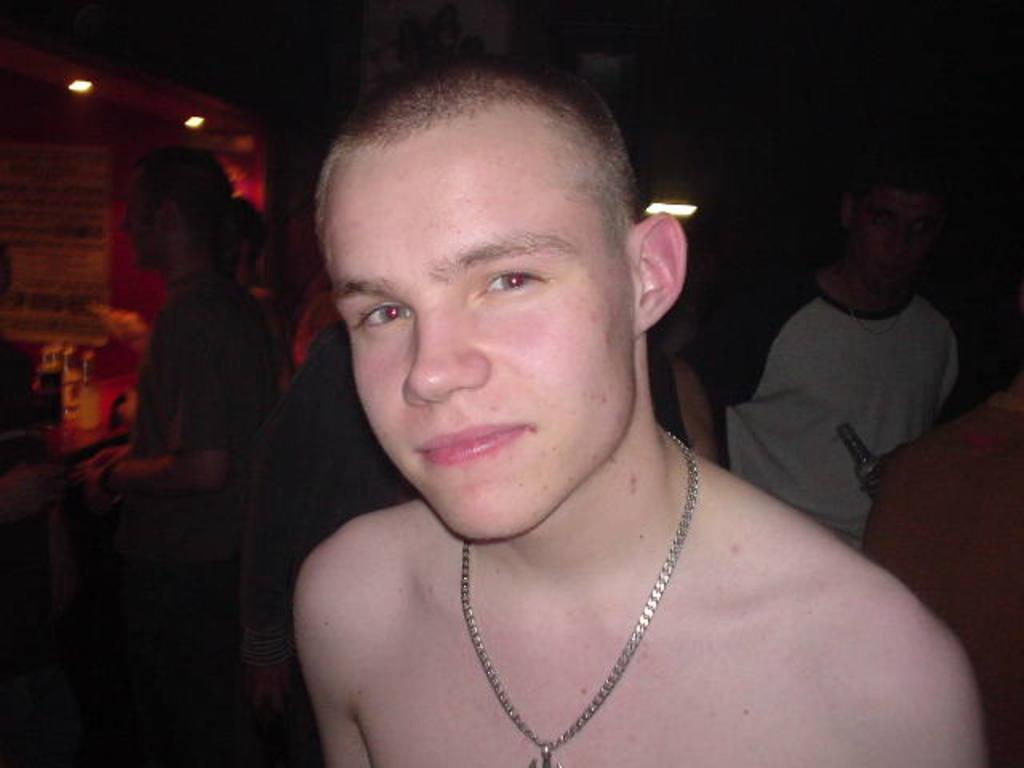How many people are in the image? There is a group of people in the image. What are the people doing in the image? The people are on the floor. What can be seen in the background of the image? There is a wall, lights, and tables in the background of the image. Where might this image have been taken? The image may have been taken in a restaurant. Can you see a friend playing with a ball near the lake in the image? There is no friend, ball, or lake present in the image. 